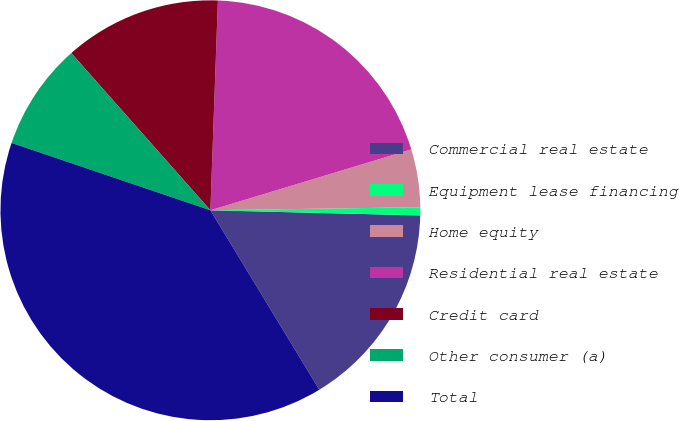<chart> <loc_0><loc_0><loc_500><loc_500><pie_chart><fcel>Commercial real estate<fcel>Equipment lease financing<fcel>Home equity<fcel>Residential real estate<fcel>Credit card<fcel>Other consumer (a)<fcel>Total<nl><fcel>15.93%<fcel>0.62%<fcel>4.45%<fcel>19.75%<fcel>12.1%<fcel>8.27%<fcel>38.88%<nl></chart> 